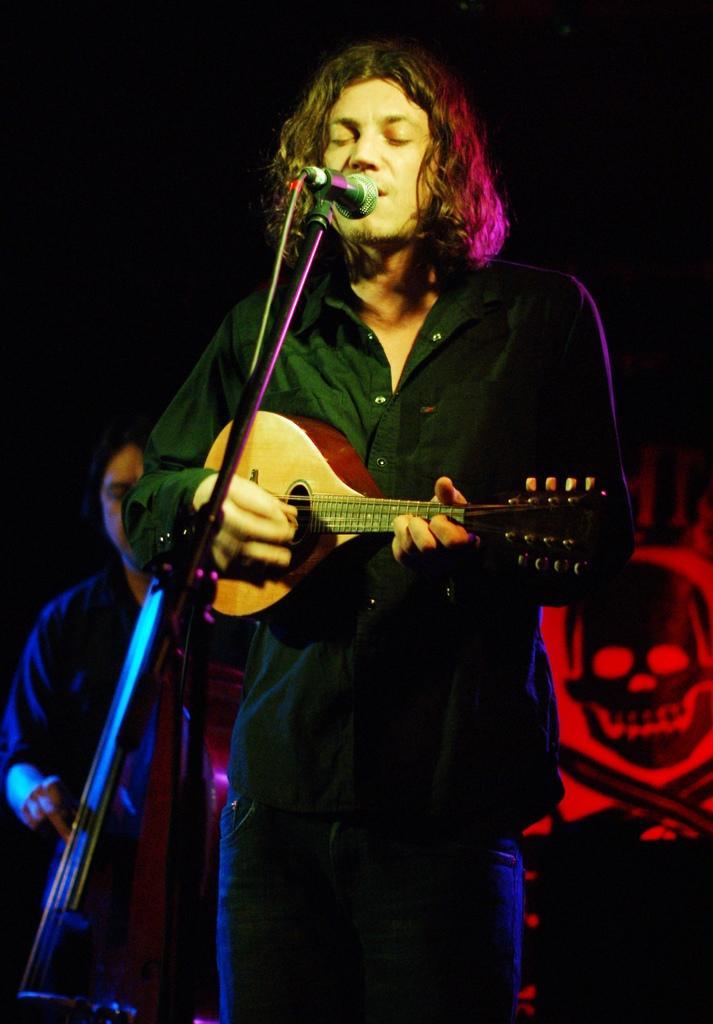Could you give a brief overview of what you see in this image? In this picture a black guy holding a guitar and singing through a mic placed in front of him. In the background we observe a guy playing a musical instrument and also a red color poster shaped as a skull. 